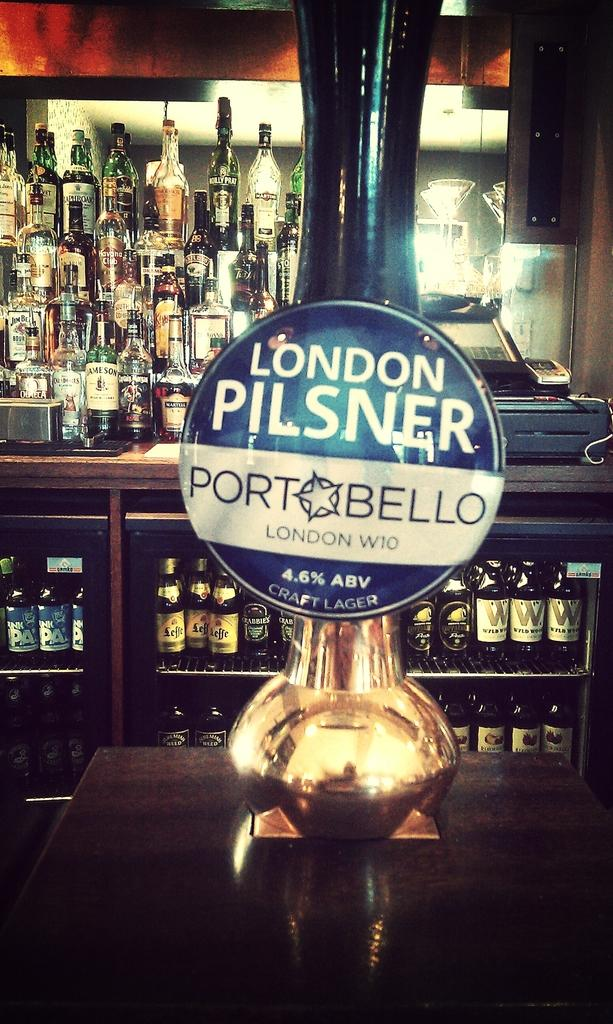<image>
Share a concise interpretation of the image provided. a draft beer of london pilsner at a bartop 